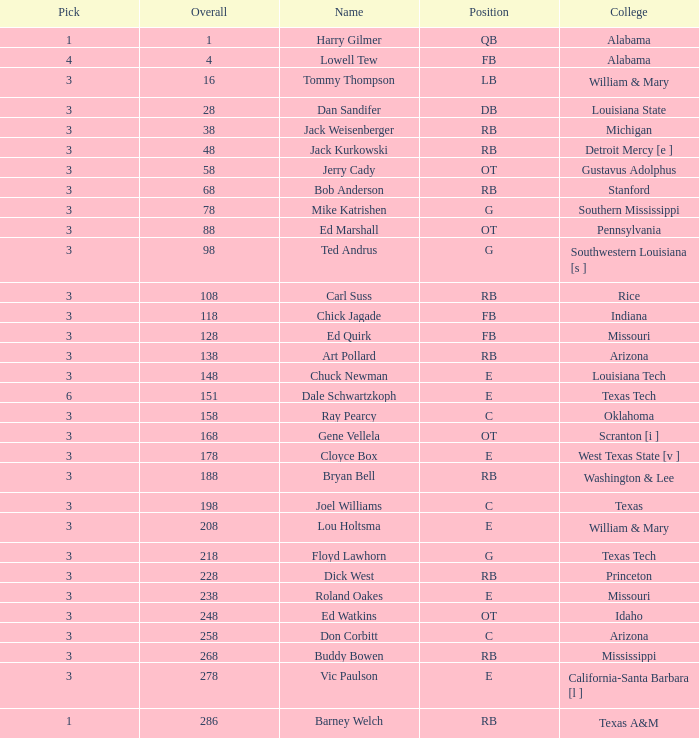What is the average aggregate for stanford? 68.0. 